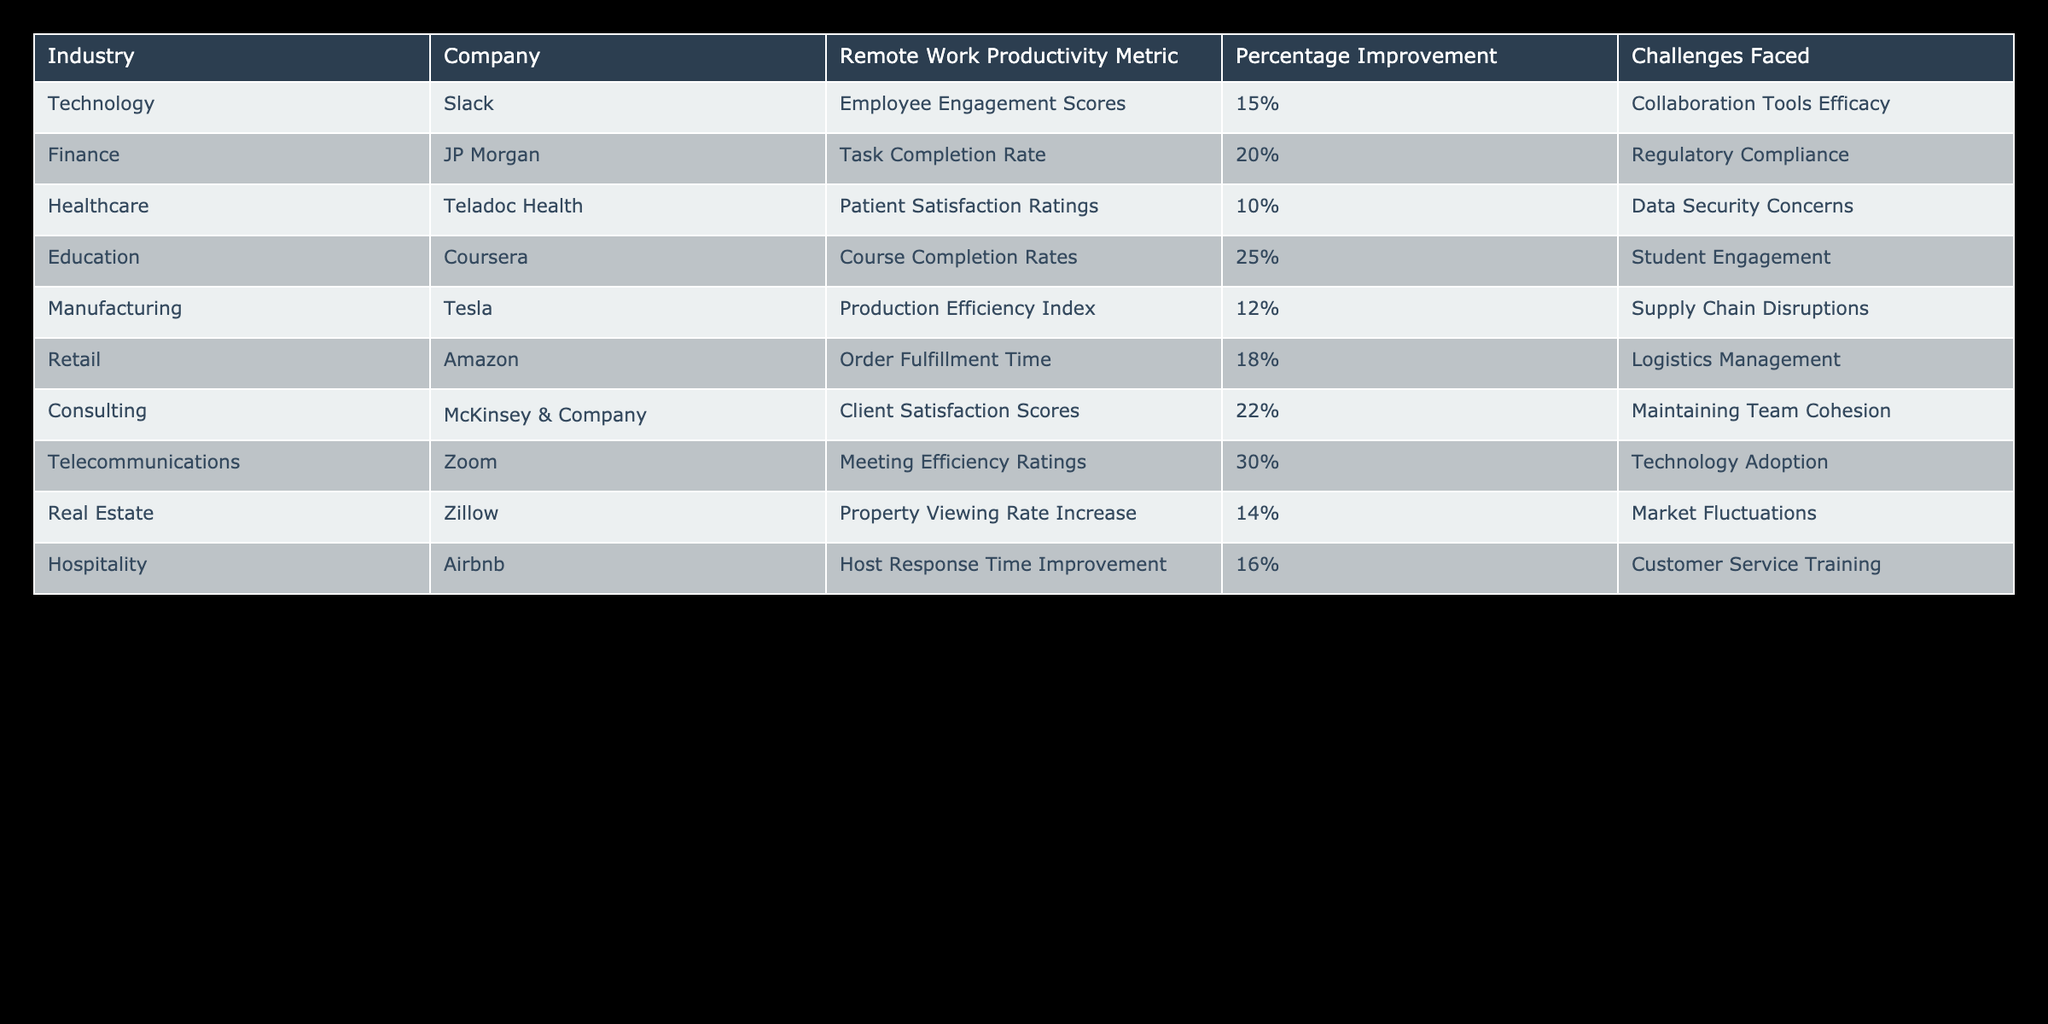What industry experienced the highest percentage improvement in remote work productivity? By examining the "Percentage Improvement" column, we find that Telecommunications (Zoom) reported a 30% improvement, which is the highest among all listed industries.
Answer: 30% What is the average percentage improvement across all industries? To find the average, we sum the percentage improvements and then divide by the total number of industries. The percentages are: 15%, 20%, 10%, 25%, 12%, 18%, 22%, 30%, 14%, 16%. Their sum is 15 + 20 + 10 + 25 + 12 + 18 + 22 + 30 + 14 + 16 = 182. Dividing by 10 (the number of entries), we get 182/10 = 18.2%.
Answer: 18.2% Did any industry report a decrease in productivity metrics? By checking each row in the table, we can confirm that all industries reported an increase in their respective productivity metrics, as indicated by the percentage improvements being positive values.
Answer: No Which two industries had the lowest percentage improvements, and what were their improvements? The industries with the lowest improvements are Healthcare (Teladoc Health) with a 10% improvement and Manufacturing (Tesla) with a 12% improvement. This can be established by comparing all entries in the "Percentage Improvement" column.
Answer: Healthcare (10%), Manufacturing (12%) What challenges does the Retail industry face regarding remote work productivity? The information in the "Challenges Faced" column shows that the Retail industry (Amazon) faces challenges related to Logistics Management. This is directly stated in the corresponding row.
Answer: Logistics Management Calculate the difference in percentage improvement between the Education and Finance industries. The percentage improvement for Education (Coursera) is 25%, while for Finance (JP Morgan) it is 20%. To find the difference, we subtract: 25% - 20% = 5%. This gives us the difference in percentage improvement between these two industries.
Answer: 5% Are the majority of industries facing challenges related to team dynamics? By reviewing the "Challenges Faced" column, we can see that only the Consulting industry mentions "Maintaining Team Cohesion", while others refer to various other challenges unrelated to team dynamics. Since only one industry faces this challenge, the majority do not face issues related to team dynamics.
Answer: No What productivity metric did the Consulting industry use to measure their remote work productivity? The table indicates that the Consulting industry (McKinsey & Company) used Client Satisfaction Scores as their productivity metric. This is found in the "Remote Work Productivity Metric" column corresponding to Consulting.
Answer: Client Satisfaction Scores 